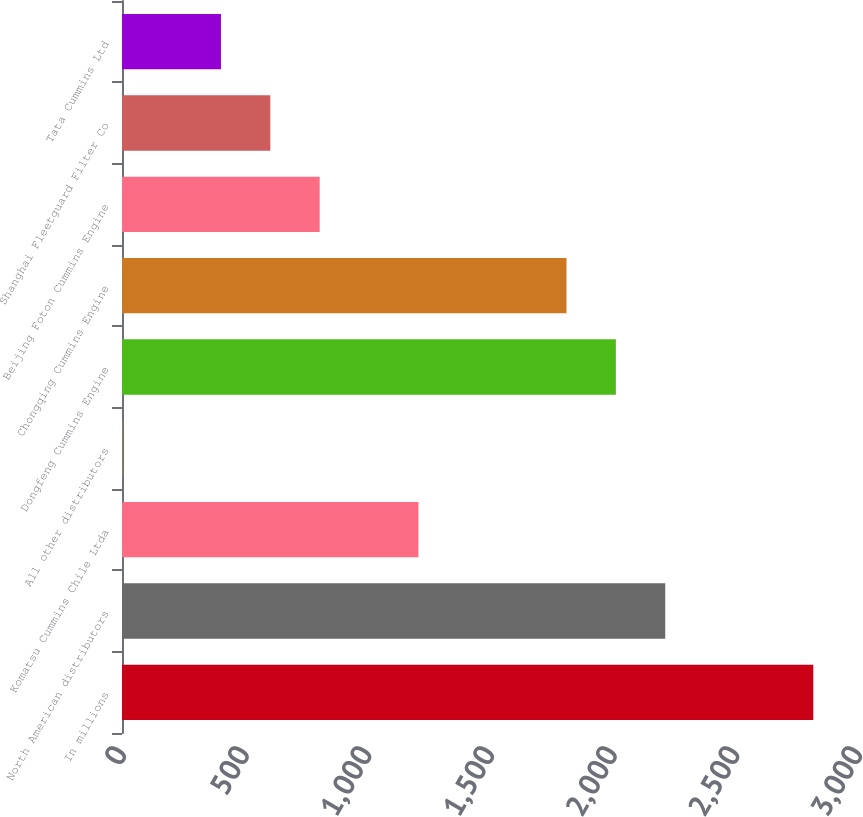Convert chart. <chart><loc_0><loc_0><loc_500><loc_500><bar_chart><fcel>In millions<fcel>North American distributors<fcel>Komatsu Cummins Chile Ltda<fcel>All other distributors<fcel>Dongfeng Cummins Engine<fcel>Chongqing Cummins Engine<fcel>Beijing Foton Cummins Engine<fcel>Shanghai Fleetguard Filter Co<fcel>Tata Cummins Ltd<nl><fcel>2817.8<fcel>2214.2<fcel>1208.2<fcel>1<fcel>2013<fcel>1811.8<fcel>805.8<fcel>604.6<fcel>403.4<nl></chart> 